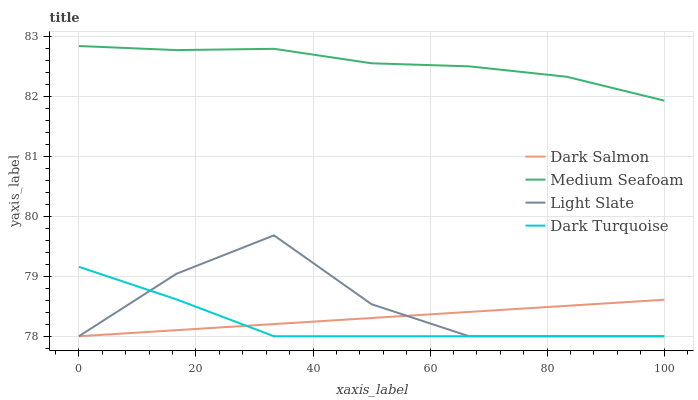Does Dark Turquoise have the minimum area under the curve?
Answer yes or no. Yes. Does Medium Seafoam have the maximum area under the curve?
Answer yes or no. Yes. Does Dark Salmon have the minimum area under the curve?
Answer yes or no. No. Does Dark Salmon have the maximum area under the curve?
Answer yes or no. No. Is Dark Salmon the smoothest?
Answer yes or no. Yes. Is Light Slate the roughest?
Answer yes or no. Yes. Is Dark Turquoise the smoothest?
Answer yes or no. No. Is Dark Turquoise the roughest?
Answer yes or no. No. Does Medium Seafoam have the lowest value?
Answer yes or no. No. Does Medium Seafoam have the highest value?
Answer yes or no. Yes. Does Dark Turquoise have the highest value?
Answer yes or no. No. Is Light Slate less than Medium Seafoam?
Answer yes or no. Yes. Is Medium Seafoam greater than Light Slate?
Answer yes or no. Yes. Does Dark Turquoise intersect Dark Salmon?
Answer yes or no. Yes. Is Dark Turquoise less than Dark Salmon?
Answer yes or no. No. Is Dark Turquoise greater than Dark Salmon?
Answer yes or no. No. Does Light Slate intersect Medium Seafoam?
Answer yes or no. No. 